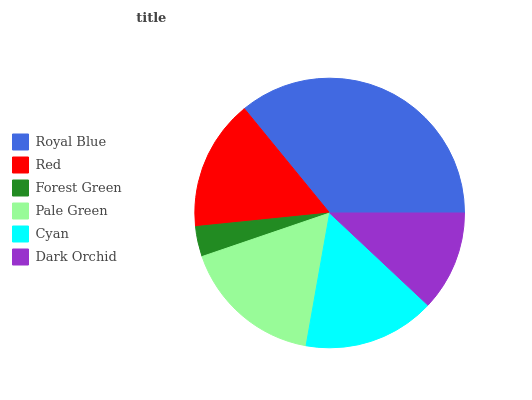Is Forest Green the minimum?
Answer yes or no. Yes. Is Royal Blue the maximum?
Answer yes or no. Yes. Is Red the minimum?
Answer yes or no. No. Is Red the maximum?
Answer yes or no. No. Is Royal Blue greater than Red?
Answer yes or no. Yes. Is Red less than Royal Blue?
Answer yes or no. Yes. Is Red greater than Royal Blue?
Answer yes or no. No. Is Royal Blue less than Red?
Answer yes or no. No. Is Cyan the high median?
Answer yes or no. Yes. Is Red the low median?
Answer yes or no. Yes. Is Forest Green the high median?
Answer yes or no. No. Is Cyan the low median?
Answer yes or no. No. 